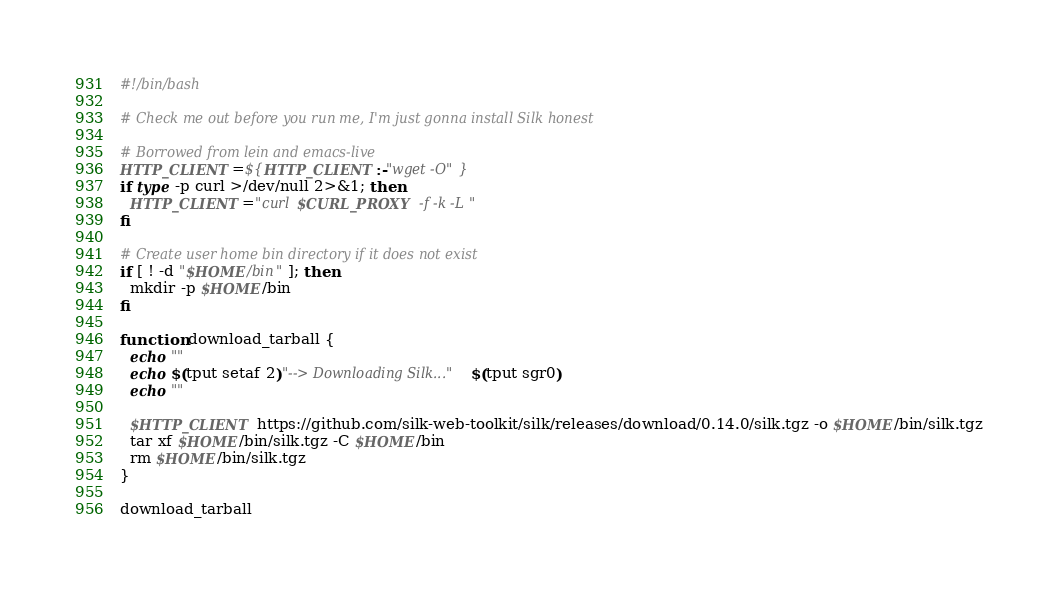<code> <loc_0><loc_0><loc_500><loc_500><_Bash_>#!/bin/bash

# Check me out before you run me, I'm just gonna install Silk honest

# Borrowed from lein and emacs-live
HTTP_CLIENT=${HTTP_CLIENT:-"wget -O"}
if type -p curl >/dev/null 2>&1; then
  HTTP_CLIENT="curl $CURL_PROXY -f -k -L"
fi

# Create user home bin directory if it does not exist
if [ ! -d "$HOME/bin" ]; then
  mkdir -p $HOME/bin
fi

function download_tarball {
  echo ""
  echo $(tput setaf 2)"--> Downloading Silk..."$(tput sgr0)
  echo ""

  $HTTP_CLIENT https://github.com/silk-web-toolkit/silk/releases/download/0.14.0/silk.tgz -o $HOME/bin/silk.tgz
  tar xf $HOME/bin/silk.tgz -C $HOME/bin
  rm $HOME/bin/silk.tgz
}

download_tarball
</code> 